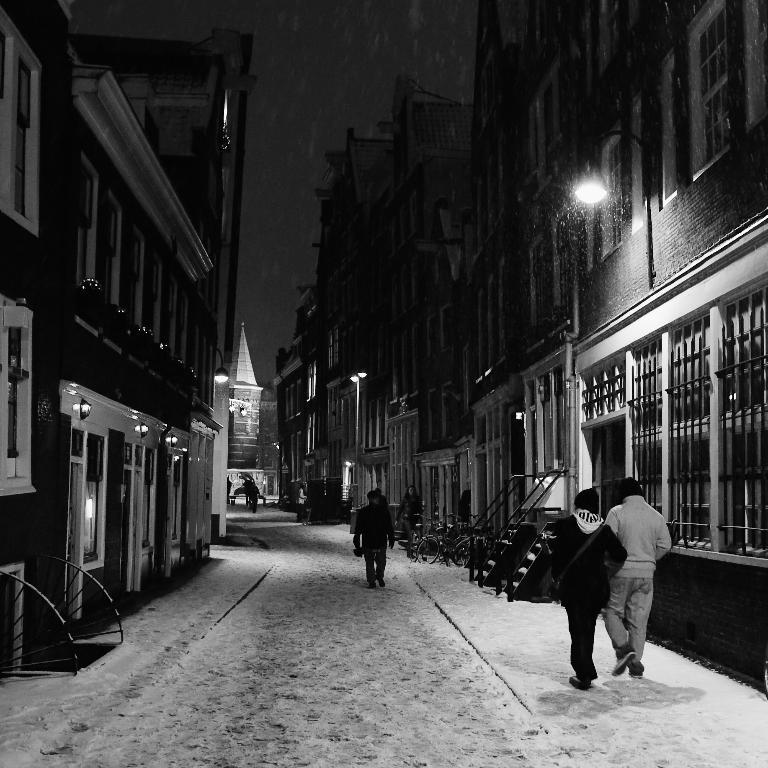What type of structures can be seen in the image? There are buildings in the image. What are the people in the image doing? People are walking on the ground in the image. What can be seen illuminating the scene in the image? There are lights visible in the image. What is visible in the background of the image? The sky is visible in the background of the image. How is the image presented in terms of color? The image is black and white in color. What type of vegetable is being used as a stamp in the image? There is no vegetable or stamp present in the image. Who is the creator of the buildings in the image? The creator of the buildings is not mentioned in the image. 